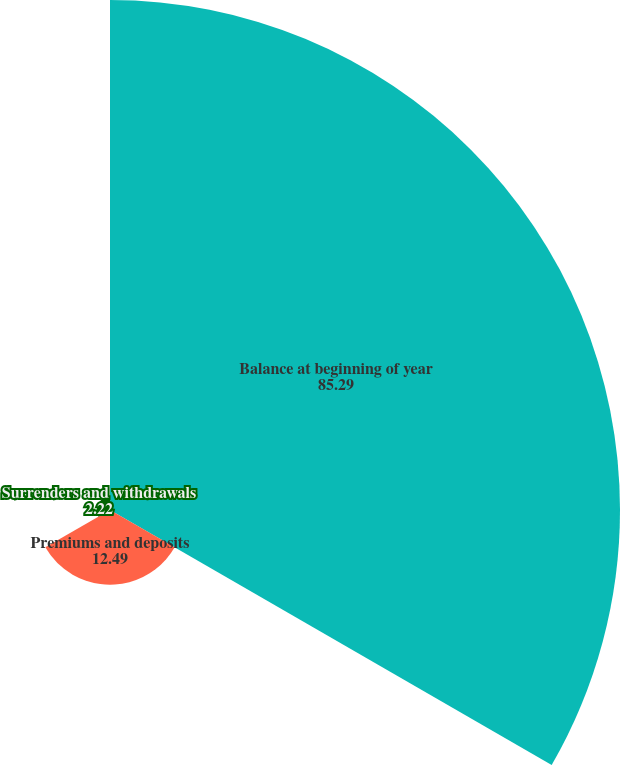Convert chart to OTSL. <chart><loc_0><loc_0><loc_500><loc_500><pie_chart><fcel>Balance at beginning of year<fcel>Premiums and deposits<fcel>Surrenders and withdrawals<nl><fcel>85.29%<fcel>12.49%<fcel>2.22%<nl></chart> 